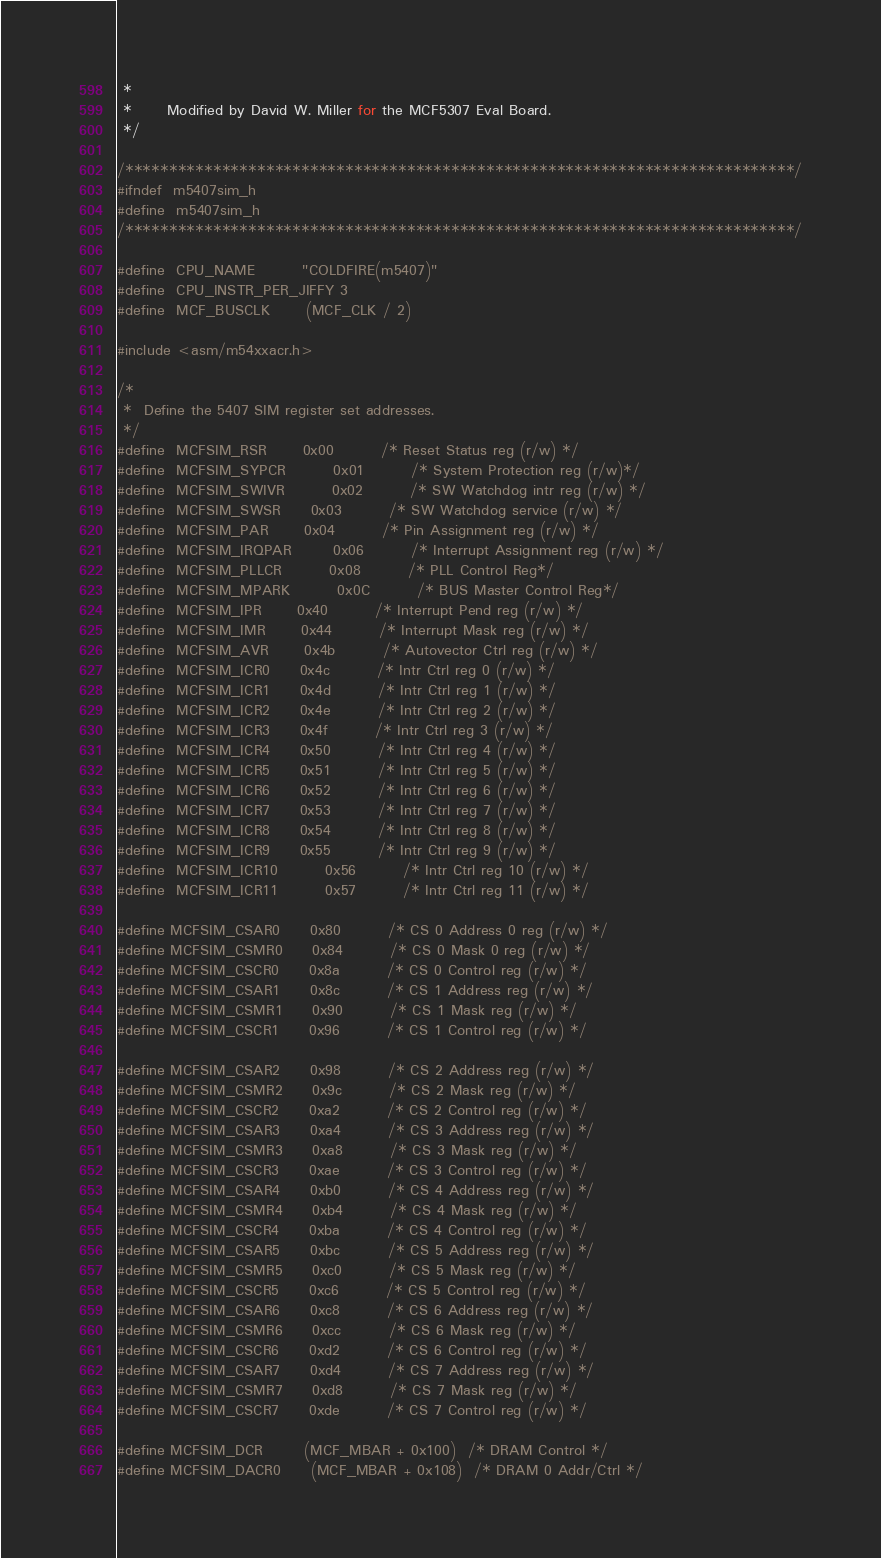Convert code to text. <code><loc_0><loc_0><loc_500><loc_500><_C_> *
 *      Modified by David W. Miller for the MCF5307 Eval Board.
 */

/****************************************************************************/
#ifndef	m5407sim_h
#define	m5407sim_h
/****************************************************************************/

#define	CPU_NAME		"COLDFIRE(m5407)"
#define	CPU_INSTR_PER_JIFFY	3
#define	MCF_BUSCLK		(MCF_CLK / 2)

#include <asm/m54xxacr.h>

/*
 *	Define the 5407 SIM register set addresses.
 */
#define	MCFSIM_RSR		0x00		/* Reset Status reg (r/w) */
#define	MCFSIM_SYPCR		0x01		/* System Protection reg (r/w)*/
#define	MCFSIM_SWIVR		0x02		/* SW Watchdog intr reg (r/w) */
#define	MCFSIM_SWSR		0x03		/* SW Watchdog service (r/w) */
#define	MCFSIM_PAR		0x04		/* Pin Assignment reg (r/w) */
#define	MCFSIM_IRQPAR		0x06		/* Interrupt Assignment reg (r/w) */
#define	MCFSIM_PLLCR		0x08		/* PLL Control Reg*/
#define	MCFSIM_MPARK		0x0C		/* BUS Master Control Reg*/
#define	MCFSIM_IPR		0x40		/* Interrupt Pend reg (r/w) */
#define	MCFSIM_IMR		0x44		/* Interrupt Mask reg (r/w) */
#define	MCFSIM_AVR		0x4b		/* Autovector Ctrl reg (r/w) */
#define	MCFSIM_ICR0		0x4c		/* Intr Ctrl reg 0 (r/w) */
#define	MCFSIM_ICR1		0x4d		/* Intr Ctrl reg 1 (r/w) */
#define	MCFSIM_ICR2		0x4e		/* Intr Ctrl reg 2 (r/w) */
#define	MCFSIM_ICR3		0x4f		/* Intr Ctrl reg 3 (r/w) */
#define	MCFSIM_ICR4		0x50		/* Intr Ctrl reg 4 (r/w) */
#define	MCFSIM_ICR5		0x51		/* Intr Ctrl reg 5 (r/w) */
#define	MCFSIM_ICR6		0x52		/* Intr Ctrl reg 6 (r/w) */
#define	MCFSIM_ICR7		0x53		/* Intr Ctrl reg 7 (r/w) */
#define	MCFSIM_ICR8		0x54		/* Intr Ctrl reg 8 (r/w) */
#define	MCFSIM_ICR9		0x55		/* Intr Ctrl reg 9 (r/w) */
#define	MCFSIM_ICR10		0x56		/* Intr Ctrl reg 10 (r/w) */
#define	MCFSIM_ICR11		0x57		/* Intr Ctrl reg 11 (r/w) */

#define MCFSIM_CSAR0		0x80		/* CS 0 Address 0 reg (r/w) */
#define MCFSIM_CSMR0		0x84		/* CS 0 Mask 0 reg (r/w) */
#define MCFSIM_CSCR0		0x8a		/* CS 0 Control reg (r/w) */
#define MCFSIM_CSAR1		0x8c		/* CS 1 Address reg (r/w) */
#define MCFSIM_CSMR1		0x90		/* CS 1 Mask reg (r/w) */
#define MCFSIM_CSCR1		0x96		/* CS 1 Control reg (r/w) */

#define MCFSIM_CSAR2		0x98		/* CS 2 Address reg (r/w) */
#define MCFSIM_CSMR2		0x9c		/* CS 2 Mask reg (r/w) */
#define MCFSIM_CSCR2		0xa2		/* CS 2 Control reg (r/w) */
#define MCFSIM_CSAR3		0xa4		/* CS 3 Address reg (r/w) */
#define MCFSIM_CSMR3		0xa8		/* CS 3 Mask reg (r/w) */
#define MCFSIM_CSCR3		0xae		/* CS 3 Control reg (r/w) */
#define MCFSIM_CSAR4		0xb0		/* CS 4 Address reg (r/w) */
#define MCFSIM_CSMR4		0xb4		/* CS 4 Mask reg (r/w) */
#define MCFSIM_CSCR4		0xba		/* CS 4 Control reg (r/w) */
#define MCFSIM_CSAR5		0xbc		/* CS 5 Address reg (r/w) */
#define MCFSIM_CSMR5		0xc0		/* CS 5 Mask reg (r/w) */
#define MCFSIM_CSCR5		0xc6		/* CS 5 Control reg (r/w) */
#define MCFSIM_CSAR6		0xc8		/* CS 6 Address reg (r/w) */
#define MCFSIM_CSMR6		0xcc		/* CS 6 Mask reg (r/w) */
#define MCFSIM_CSCR6		0xd2		/* CS 6 Control reg (r/w) */
#define MCFSIM_CSAR7		0xd4		/* CS 7 Address reg (r/w) */
#define MCFSIM_CSMR7		0xd8		/* CS 7 Mask reg (r/w) */
#define MCFSIM_CSCR7		0xde		/* CS 7 Control reg (r/w) */

#define MCFSIM_DCR		(MCF_MBAR + 0x100)	/* DRAM Control */
#define MCFSIM_DACR0		(MCF_MBAR + 0x108)	/* DRAM 0 Addr/Ctrl */</code> 